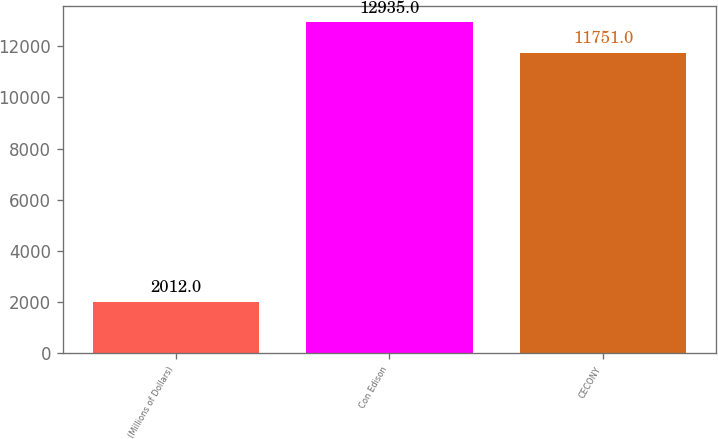<chart> <loc_0><loc_0><loc_500><loc_500><bar_chart><fcel>(Millions of Dollars)<fcel>Con Edison<fcel>CECONY<nl><fcel>2012<fcel>12935<fcel>11751<nl></chart> 